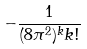Convert formula to latex. <formula><loc_0><loc_0><loc_500><loc_500>- \frac { 1 } { ( 8 \pi ^ { 2 } ) ^ { k } k ! }</formula> 